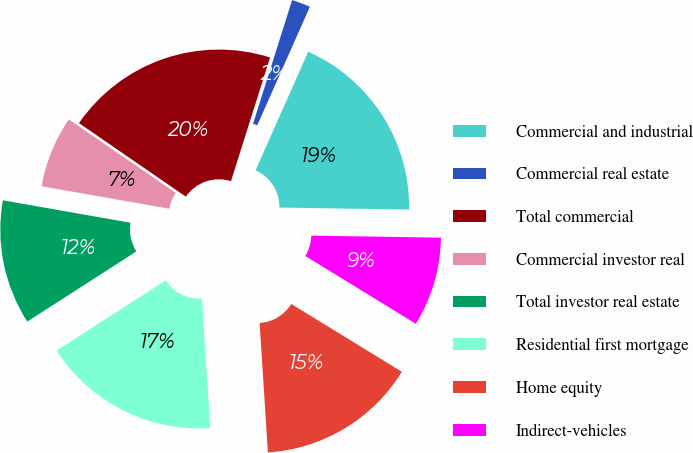Convert chart to OTSL. <chart><loc_0><loc_0><loc_500><loc_500><pie_chart><fcel>Commercial and industrial<fcel>Commercial real estate<fcel>Total commercial<fcel>Commercial investor real<fcel>Total investor real estate<fcel>Residential first mortgage<fcel>Home equity<fcel>Indirect-vehicles<nl><fcel>18.6%<fcel>1.78%<fcel>20.28%<fcel>6.82%<fcel>11.87%<fcel>16.92%<fcel>15.23%<fcel>8.51%<nl></chart> 